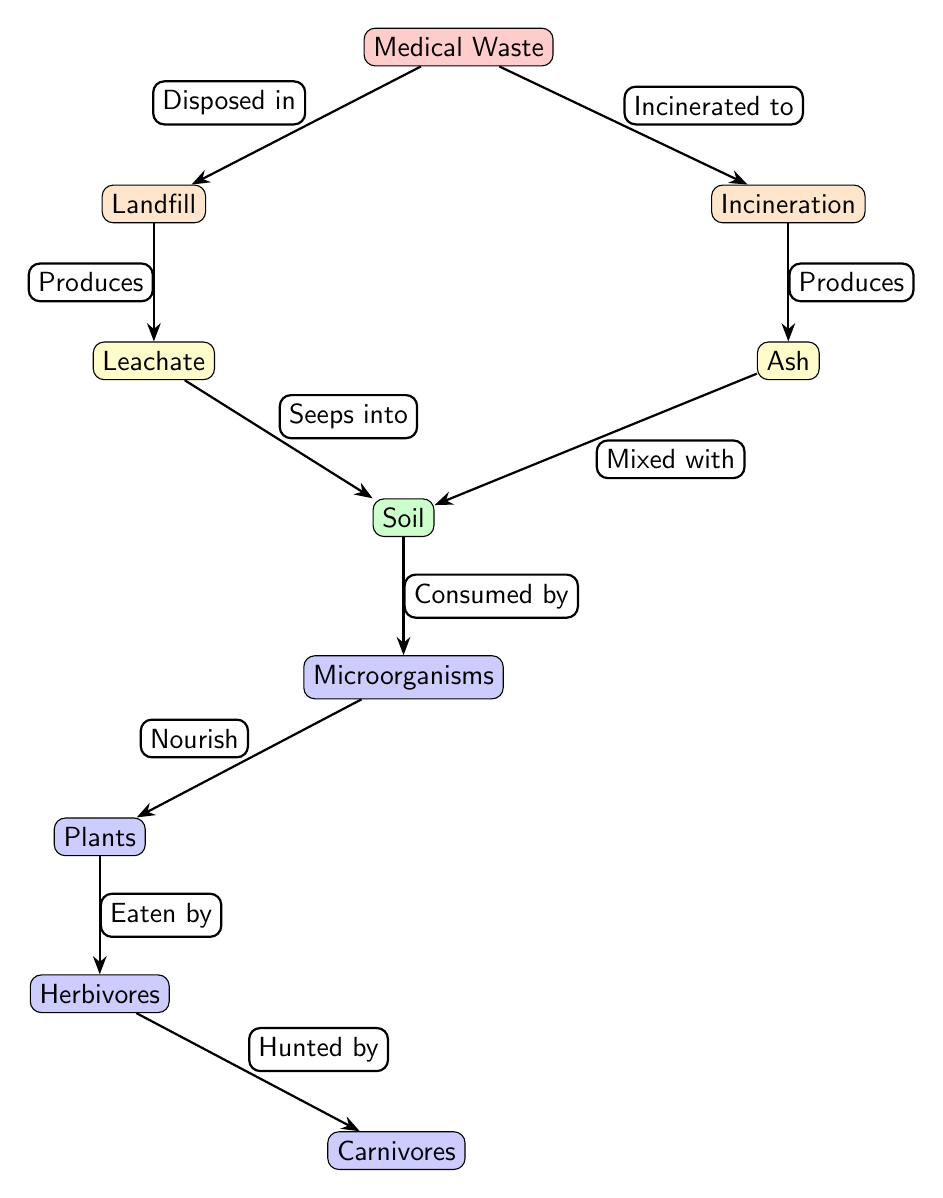What is the final organism in the sequence? The diagram indicates the flow from herbivores to carnivores, making carnivores the final organism in this food chain.
Answer: Carnivores How many types of waste disposal methods are shown? The diagram lists two methods for disposing of medical waste: landfill and incineration, totaling two types.
Answer: 2 What byproduct is produced from landfill disposal? According to the diagram, leachate is the byproduct generated from medical waste disposal in a landfill.
Answer: Leachate What do microorganisms consume according to the diagram? The diagram shows that microorganisms consume soil, which indicates their role in nutrient cycling.
Answer: Soil Who consumes plants in this food chain? The diagram specifies that herbivores eat plants, highlighting their position in the food chain.
Answer: Herbivores What is mixed with ash from incineration? The diagram indicates that ash is combined with soil, pointing to a process of degradation and nutrient replenishment.
Answer: Soil Which element in the diagram is a byproduct of incineration? The diagram states that ash is produced as a byproduct of the incineration method for medical waste.
Answer: Ash How does leachate affect the ecosystem? Leachate seeps into the soil, indicating its role in the potential contamination and nutrient flow in the ecosystem.
Answer: Soil What role do plants play after being nourished by microorganisms? The diagram shows that plants are consumed by herbivores, positioning them as primary producers in the food chain.
Answer: Herbivores 